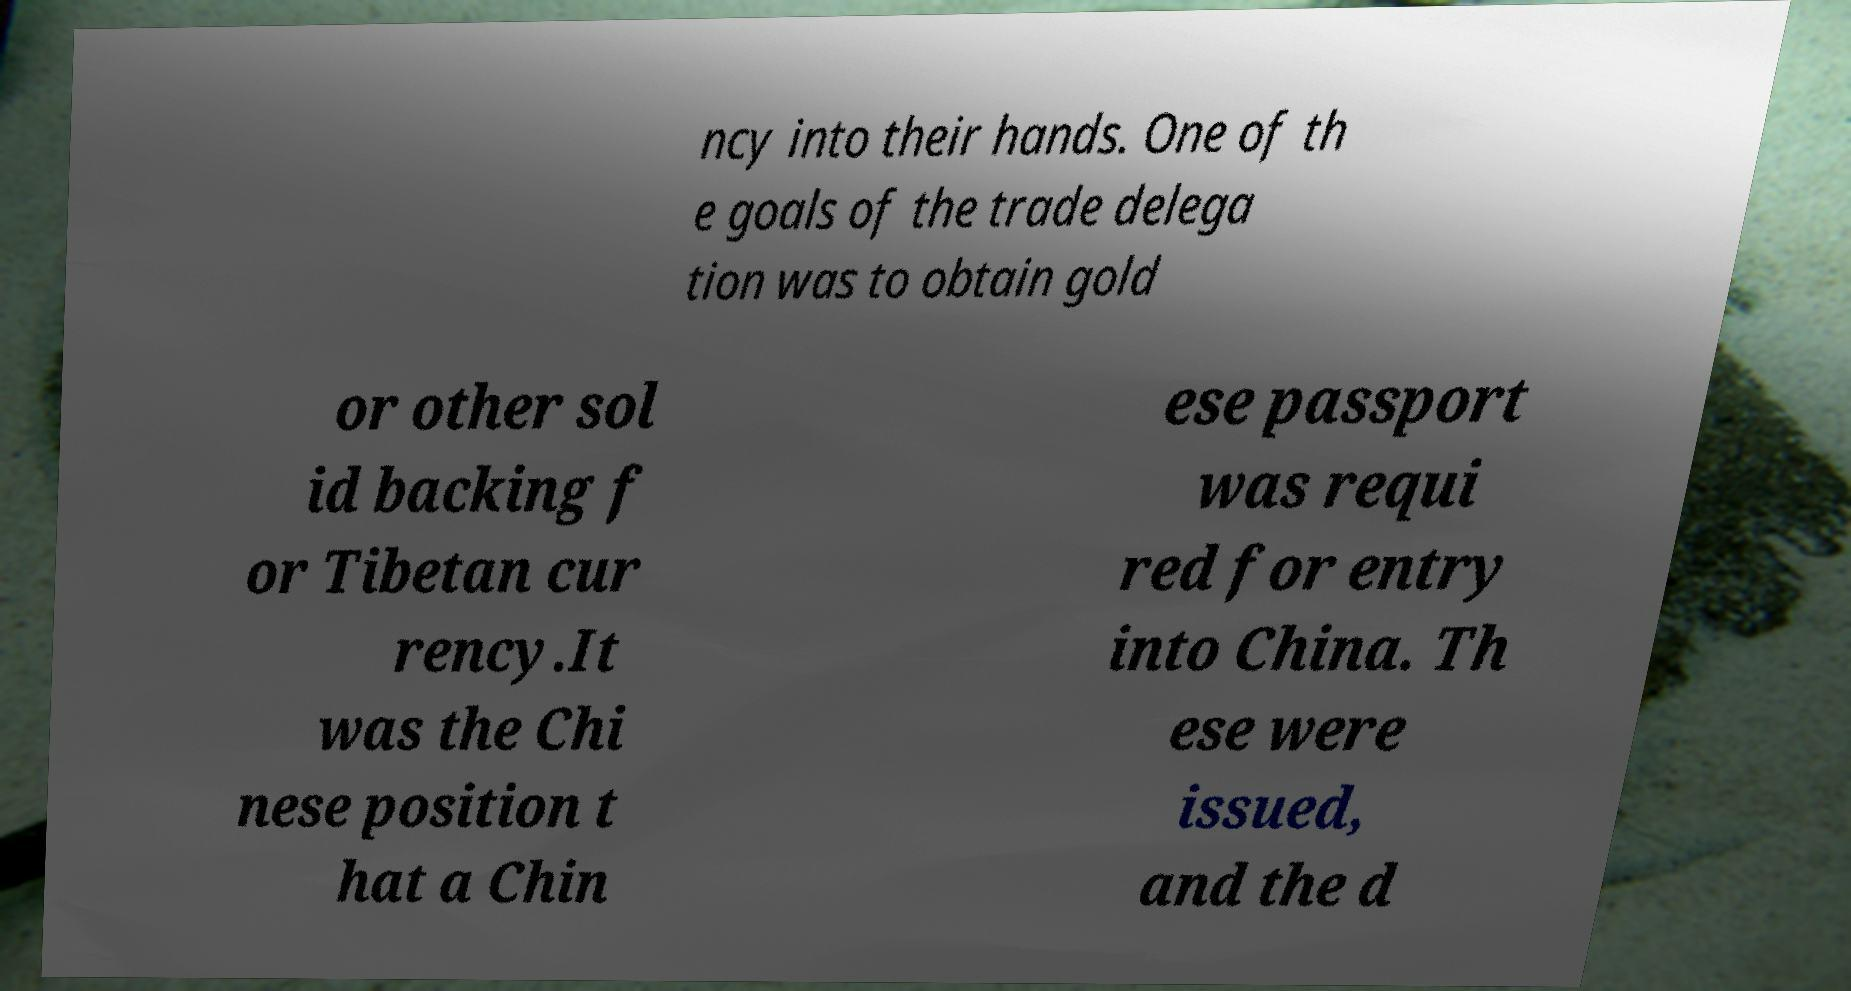There's text embedded in this image that I need extracted. Can you transcribe it verbatim? ncy into their hands. One of th e goals of the trade delega tion was to obtain gold or other sol id backing f or Tibetan cur rency.It was the Chi nese position t hat a Chin ese passport was requi red for entry into China. Th ese were issued, and the d 